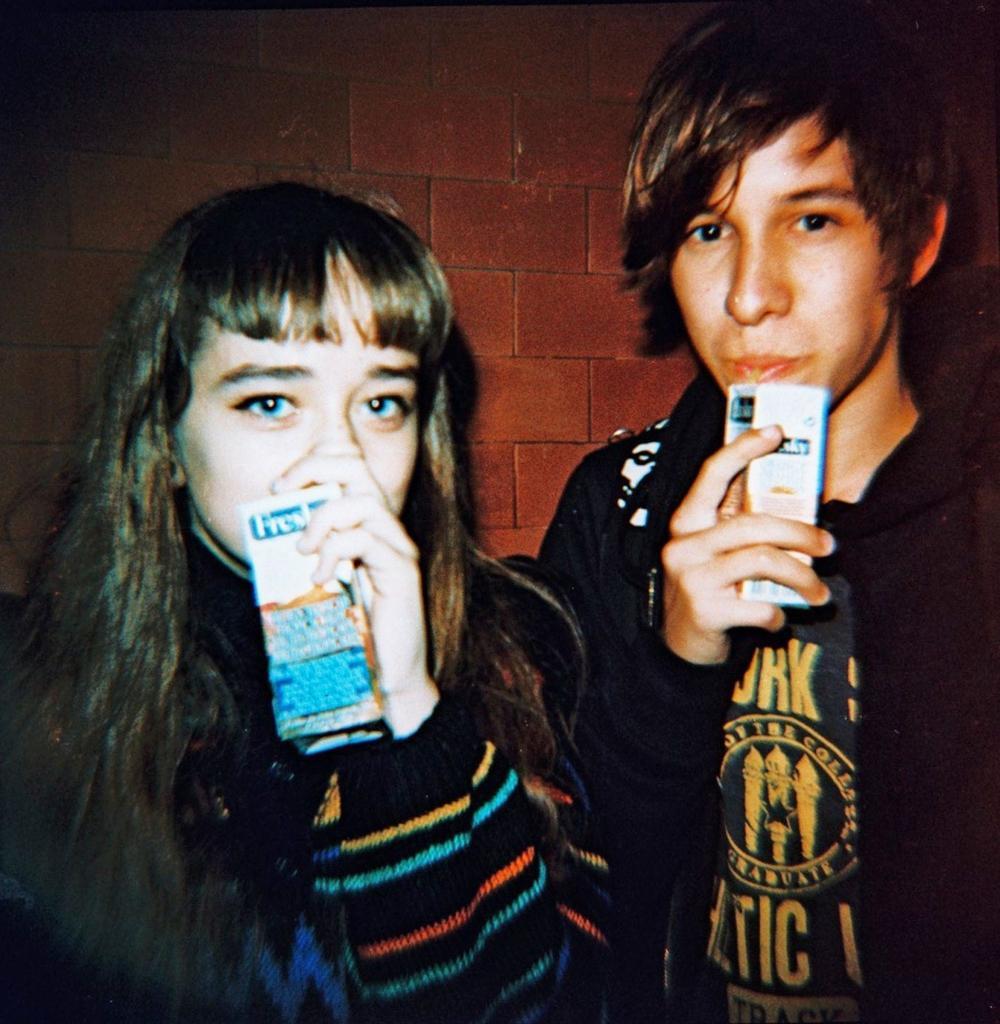In one or two sentences, can you explain what this image depicts? In this picture we can see a wall on the background with red colour. On the right side of the picture there is man standing wearing a black Shirt and a black jacket. Beside him there is a pretty women with a long hair wearing a sweater, holding a juice drink in her hands. This is a straw. 